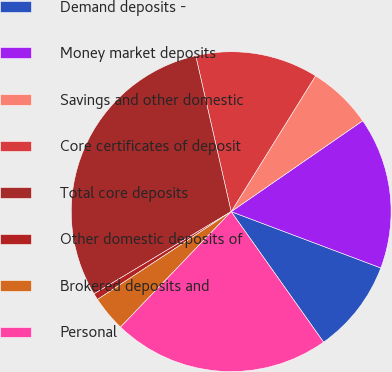Convert chart to OTSL. <chart><loc_0><loc_0><loc_500><loc_500><pie_chart><fcel>Demand deposits -<fcel>Money market deposits<fcel>Savings and other domestic<fcel>Core certificates of deposit<fcel>Total core deposits<fcel>Other domestic deposits of<fcel>Brokered deposits and<fcel>Personal<nl><fcel>9.47%<fcel>15.35%<fcel>6.53%<fcel>12.41%<fcel>30.05%<fcel>0.65%<fcel>3.59%<fcel>21.97%<nl></chart> 